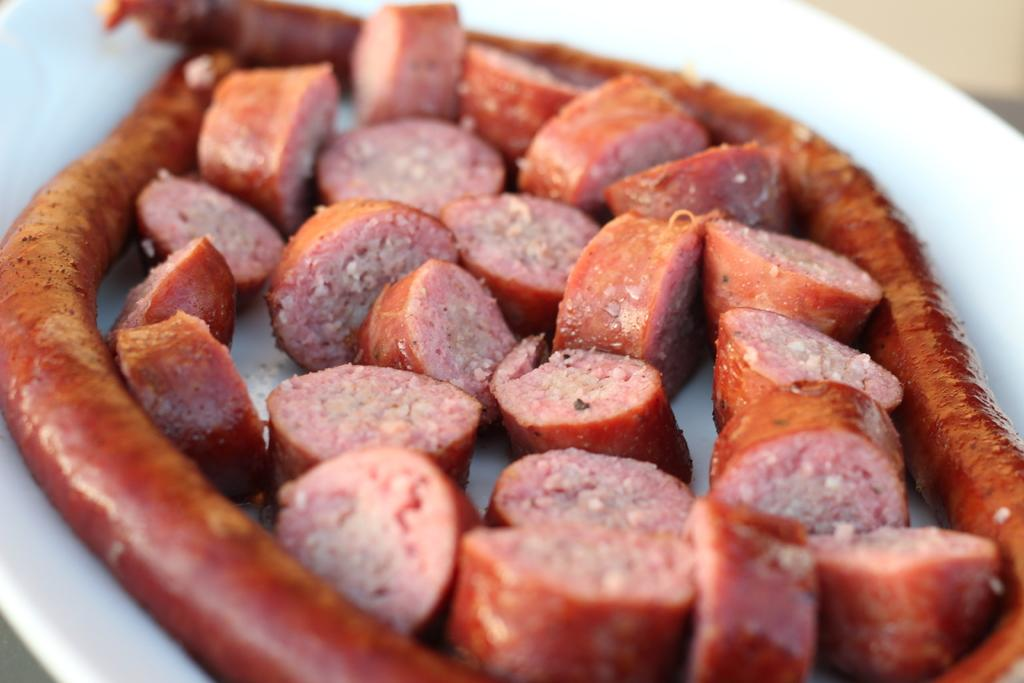What can be seen on the plate in the image? There is food stuff on the plate. Can you describe the plate in the image? The plate is visible in the image, but there is no specific description provided. What type of dust can be seen on the plate in the image? There is no dust visible on the plate in the image. 